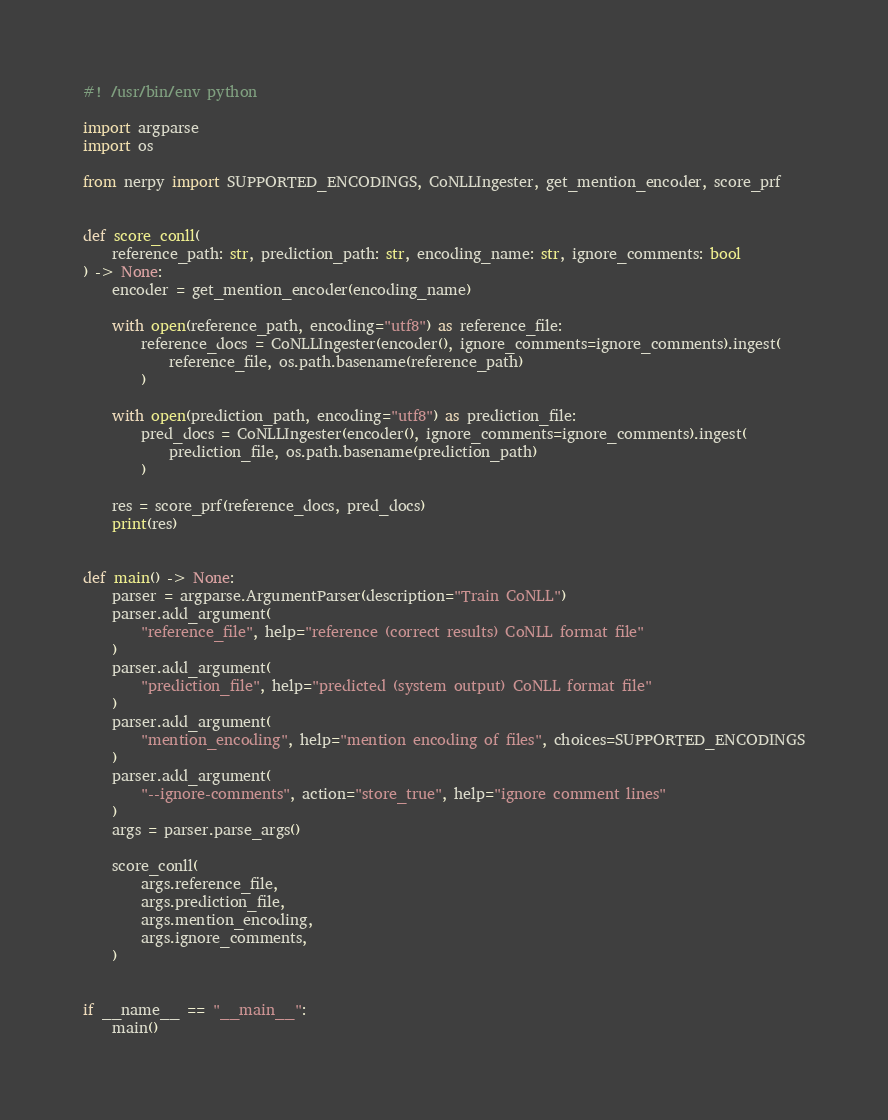<code> <loc_0><loc_0><loc_500><loc_500><_Python_>#! /usr/bin/env python

import argparse
import os

from nerpy import SUPPORTED_ENCODINGS, CoNLLIngester, get_mention_encoder, score_prf


def score_conll(
    reference_path: str, prediction_path: str, encoding_name: str, ignore_comments: bool
) -> None:
    encoder = get_mention_encoder(encoding_name)

    with open(reference_path, encoding="utf8") as reference_file:
        reference_docs = CoNLLIngester(encoder(), ignore_comments=ignore_comments).ingest(
            reference_file, os.path.basename(reference_path)
        )

    with open(prediction_path, encoding="utf8") as prediction_file:
        pred_docs = CoNLLIngester(encoder(), ignore_comments=ignore_comments).ingest(
            prediction_file, os.path.basename(prediction_path)
        )

    res = score_prf(reference_docs, pred_docs)
    print(res)


def main() -> None:
    parser = argparse.ArgumentParser(description="Train CoNLL")
    parser.add_argument(
        "reference_file", help="reference (correct results) CoNLL format file"
    )
    parser.add_argument(
        "prediction_file", help="predicted (system output) CoNLL format file"
    )
    parser.add_argument(
        "mention_encoding", help="mention encoding of files", choices=SUPPORTED_ENCODINGS
    )
    parser.add_argument(
        "--ignore-comments", action="store_true", help="ignore comment lines"
    )
    args = parser.parse_args()

    score_conll(
        args.reference_file,
        args.prediction_file,
        args.mention_encoding,
        args.ignore_comments,
    )


if __name__ == "__main__":
    main()
</code> 